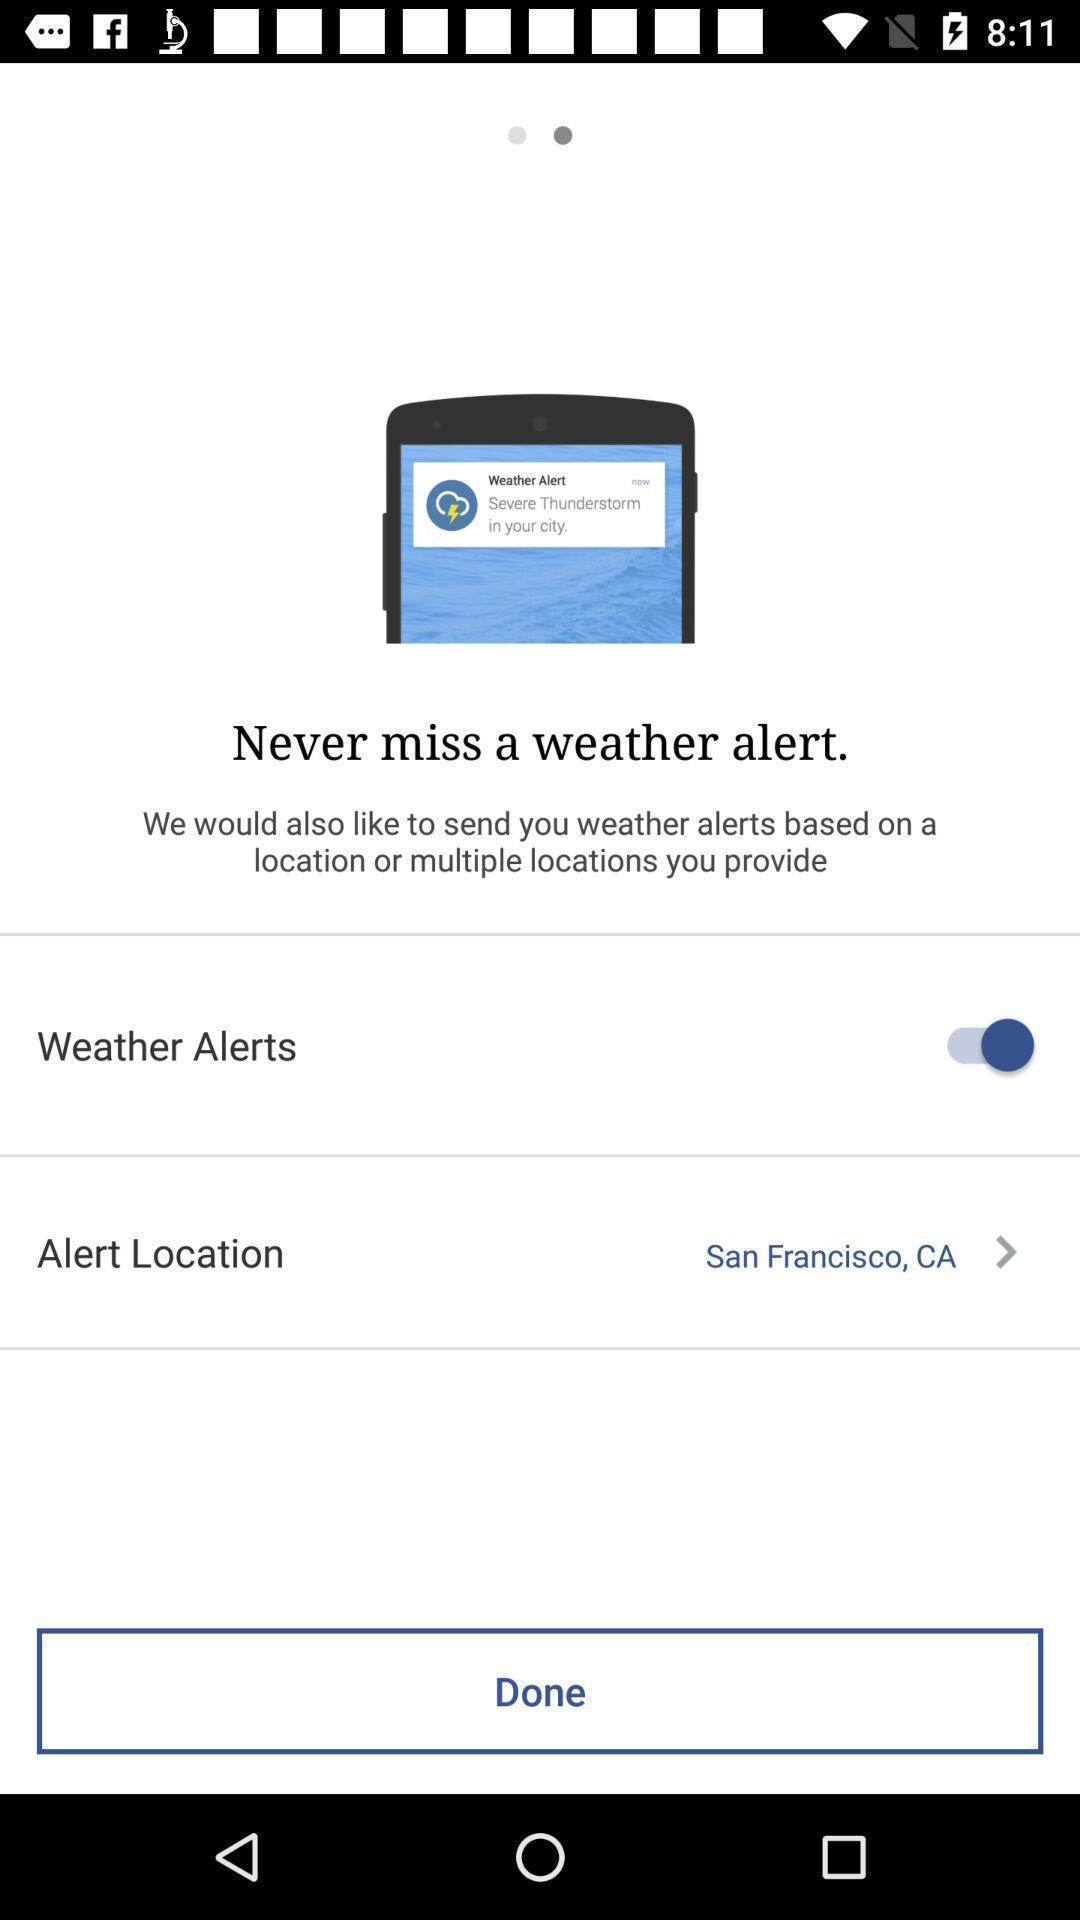What can you discern from this picture? Weather alerts in never miss weather alert. 